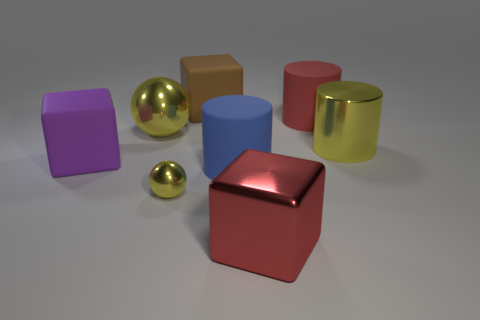Subtract all gray spheres. Subtract all purple cylinders. How many spheres are left? 2 Add 1 big red cylinders. How many objects exist? 9 Subtract all cubes. How many objects are left? 5 Add 8 green things. How many green things exist? 8 Subtract 0 gray cubes. How many objects are left? 8 Subtract all large blue blocks. Subtract all large metallic cylinders. How many objects are left? 7 Add 6 cylinders. How many cylinders are left? 9 